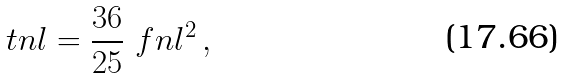Convert formula to latex. <formula><loc_0><loc_0><loc_500><loc_500>\ t n l = \frac { 3 6 } { 2 5 } \ f n l ^ { 2 } \, ,</formula> 